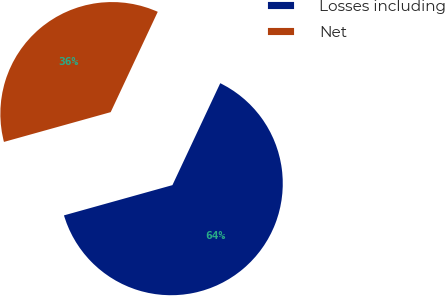Convert chart to OTSL. <chart><loc_0><loc_0><loc_500><loc_500><pie_chart><fcel>Losses including<fcel>Net<nl><fcel>63.69%<fcel>36.31%<nl></chart> 